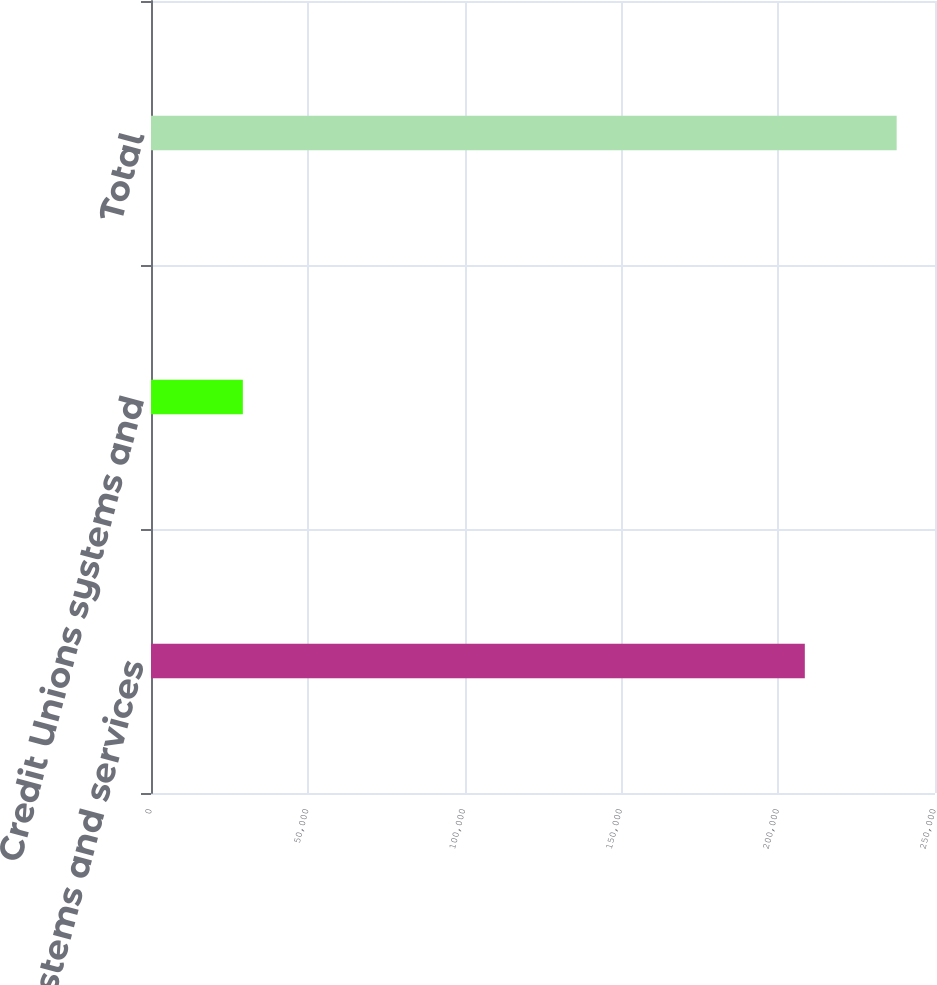Convert chart to OTSL. <chart><loc_0><loc_0><loc_500><loc_500><bar_chart><fcel>Bank systems and services<fcel>Credit Unions systems and<fcel>Total<nl><fcel>208488<fcel>29290<fcel>237778<nl></chart> 